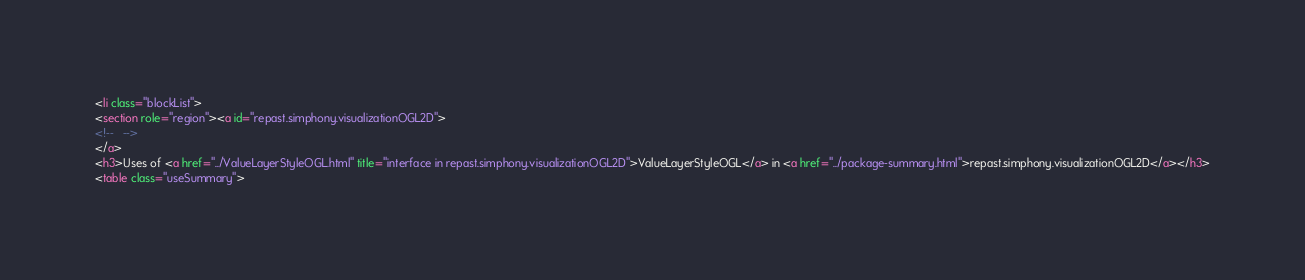<code> <loc_0><loc_0><loc_500><loc_500><_HTML_><li class="blockList">
<section role="region"><a id="repast.simphony.visualizationOGL2D">
<!--   -->
</a>
<h3>Uses of <a href="../ValueLayerStyleOGL.html" title="interface in repast.simphony.visualizationOGL2D">ValueLayerStyleOGL</a> in <a href="../package-summary.html">repast.simphony.visualizationOGL2D</a></h3>
<table class="useSummary"></code> 